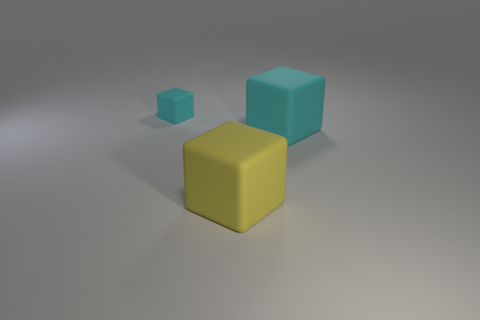There is another cube that is the same color as the tiny cube; what is it made of?
Make the answer very short. Rubber. What number of large matte cubes are the same color as the small rubber cube?
Your answer should be compact. 1. Are there any small rubber objects of the same shape as the big cyan thing?
Make the answer very short. Yes. Is the number of gray blocks less than the number of small cyan things?
Provide a short and direct response. Yes. Does the cyan thing that is on the right side of the big yellow rubber cube have the same size as the matte cube that is to the left of the big yellow rubber cube?
Make the answer very short. No. What number of objects are either large purple matte cylinders or big things?
Your response must be concise. 2. There is a matte thing in front of the big cyan matte block; how big is it?
Your answer should be very brief. Large. How many objects are right of the small cyan object left of the cyan matte block that is to the right of the tiny block?
Your answer should be compact. 2. How many things are both left of the big cyan matte object and to the right of the tiny block?
Your response must be concise. 1. What shape is the cyan matte object that is on the right side of the small cyan matte thing?
Offer a very short reply. Cube. 